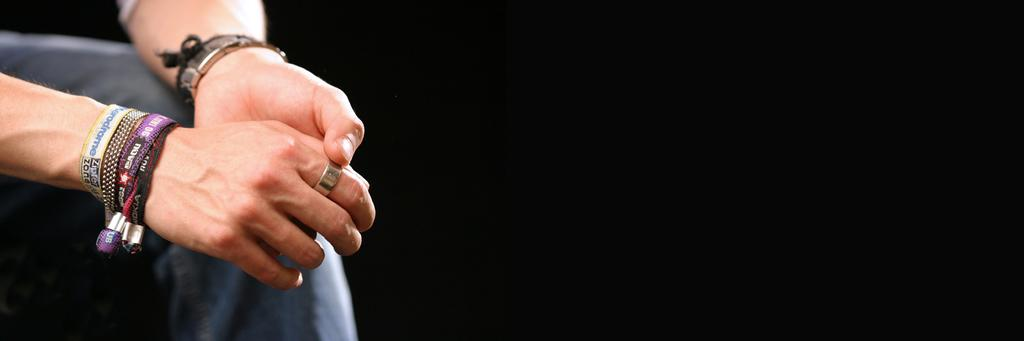What body parts are visible in the image? There are a person's hands in the image. What is on the person's hands? The person's hands have bands on them. Are there any accessories on the person's fingers? Yes, there is a ring on one of the person's fingers. What else can be seen under the hands in the image? A leg is visible under the hands in the image. What type of cracker is being held by the person's hands in the image? There is no cracker present in the image; only the person's hands, bands, ring, and leg are visible. 